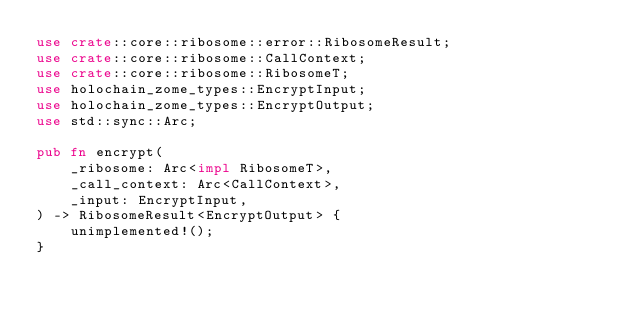<code> <loc_0><loc_0><loc_500><loc_500><_Rust_>use crate::core::ribosome::error::RibosomeResult;
use crate::core::ribosome::CallContext;
use crate::core::ribosome::RibosomeT;
use holochain_zome_types::EncryptInput;
use holochain_zome_types::EncryptOutput;
use std::sync::Arc;

pub fn encrypt(
    _ribosome: Arc<impl RibosomeT>,
    _call_context: Arc<CallContext>,
    _input: EncryptInput,
) -> RibosomeResult<EncryptOutput> {
    unimplemented!();
}
</code> 